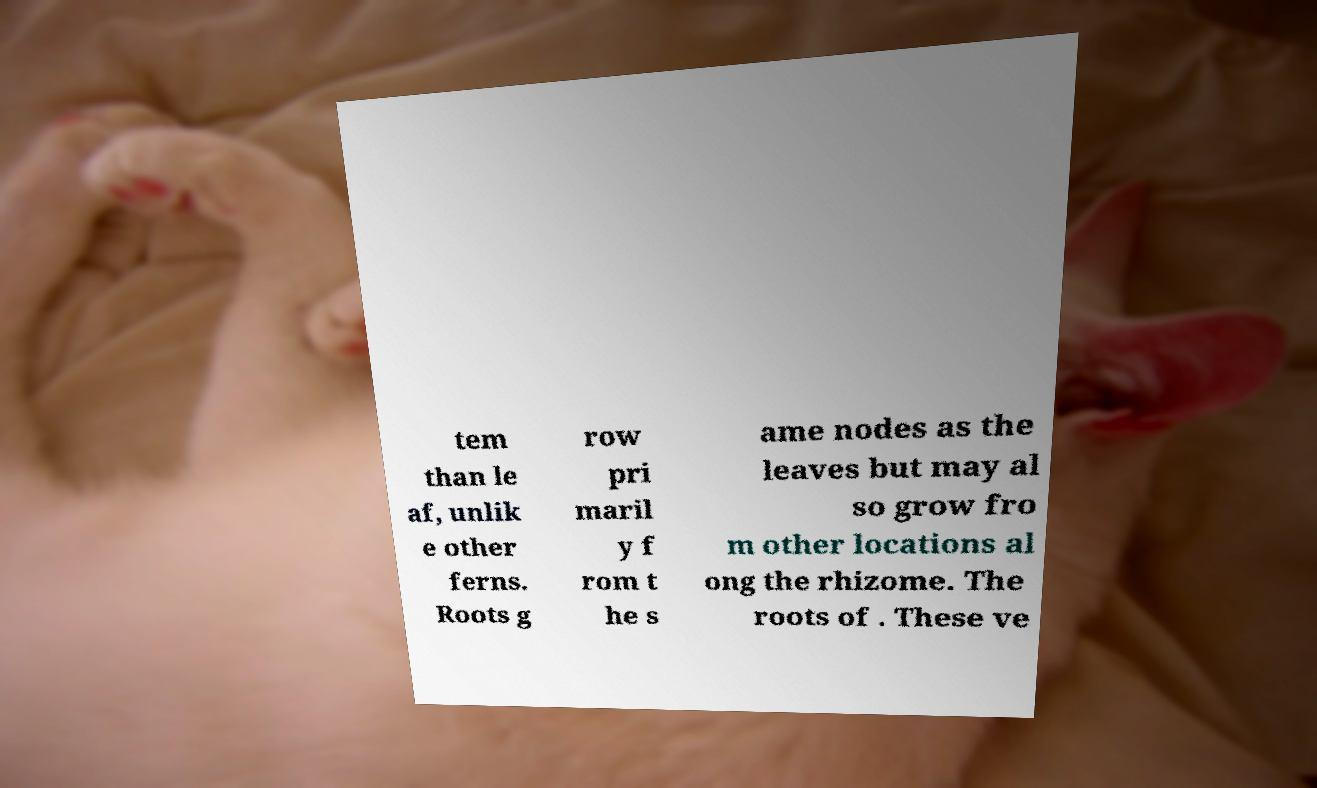Could you assist in decoding the text presented in this image and type it out clearly? tem than le af, unlik e other ferns. Roots g row pri maril y f rom t he s ame nodes as the leaves but may al so grow fro m other locations al ong the rhizome. The roots of . These ve 